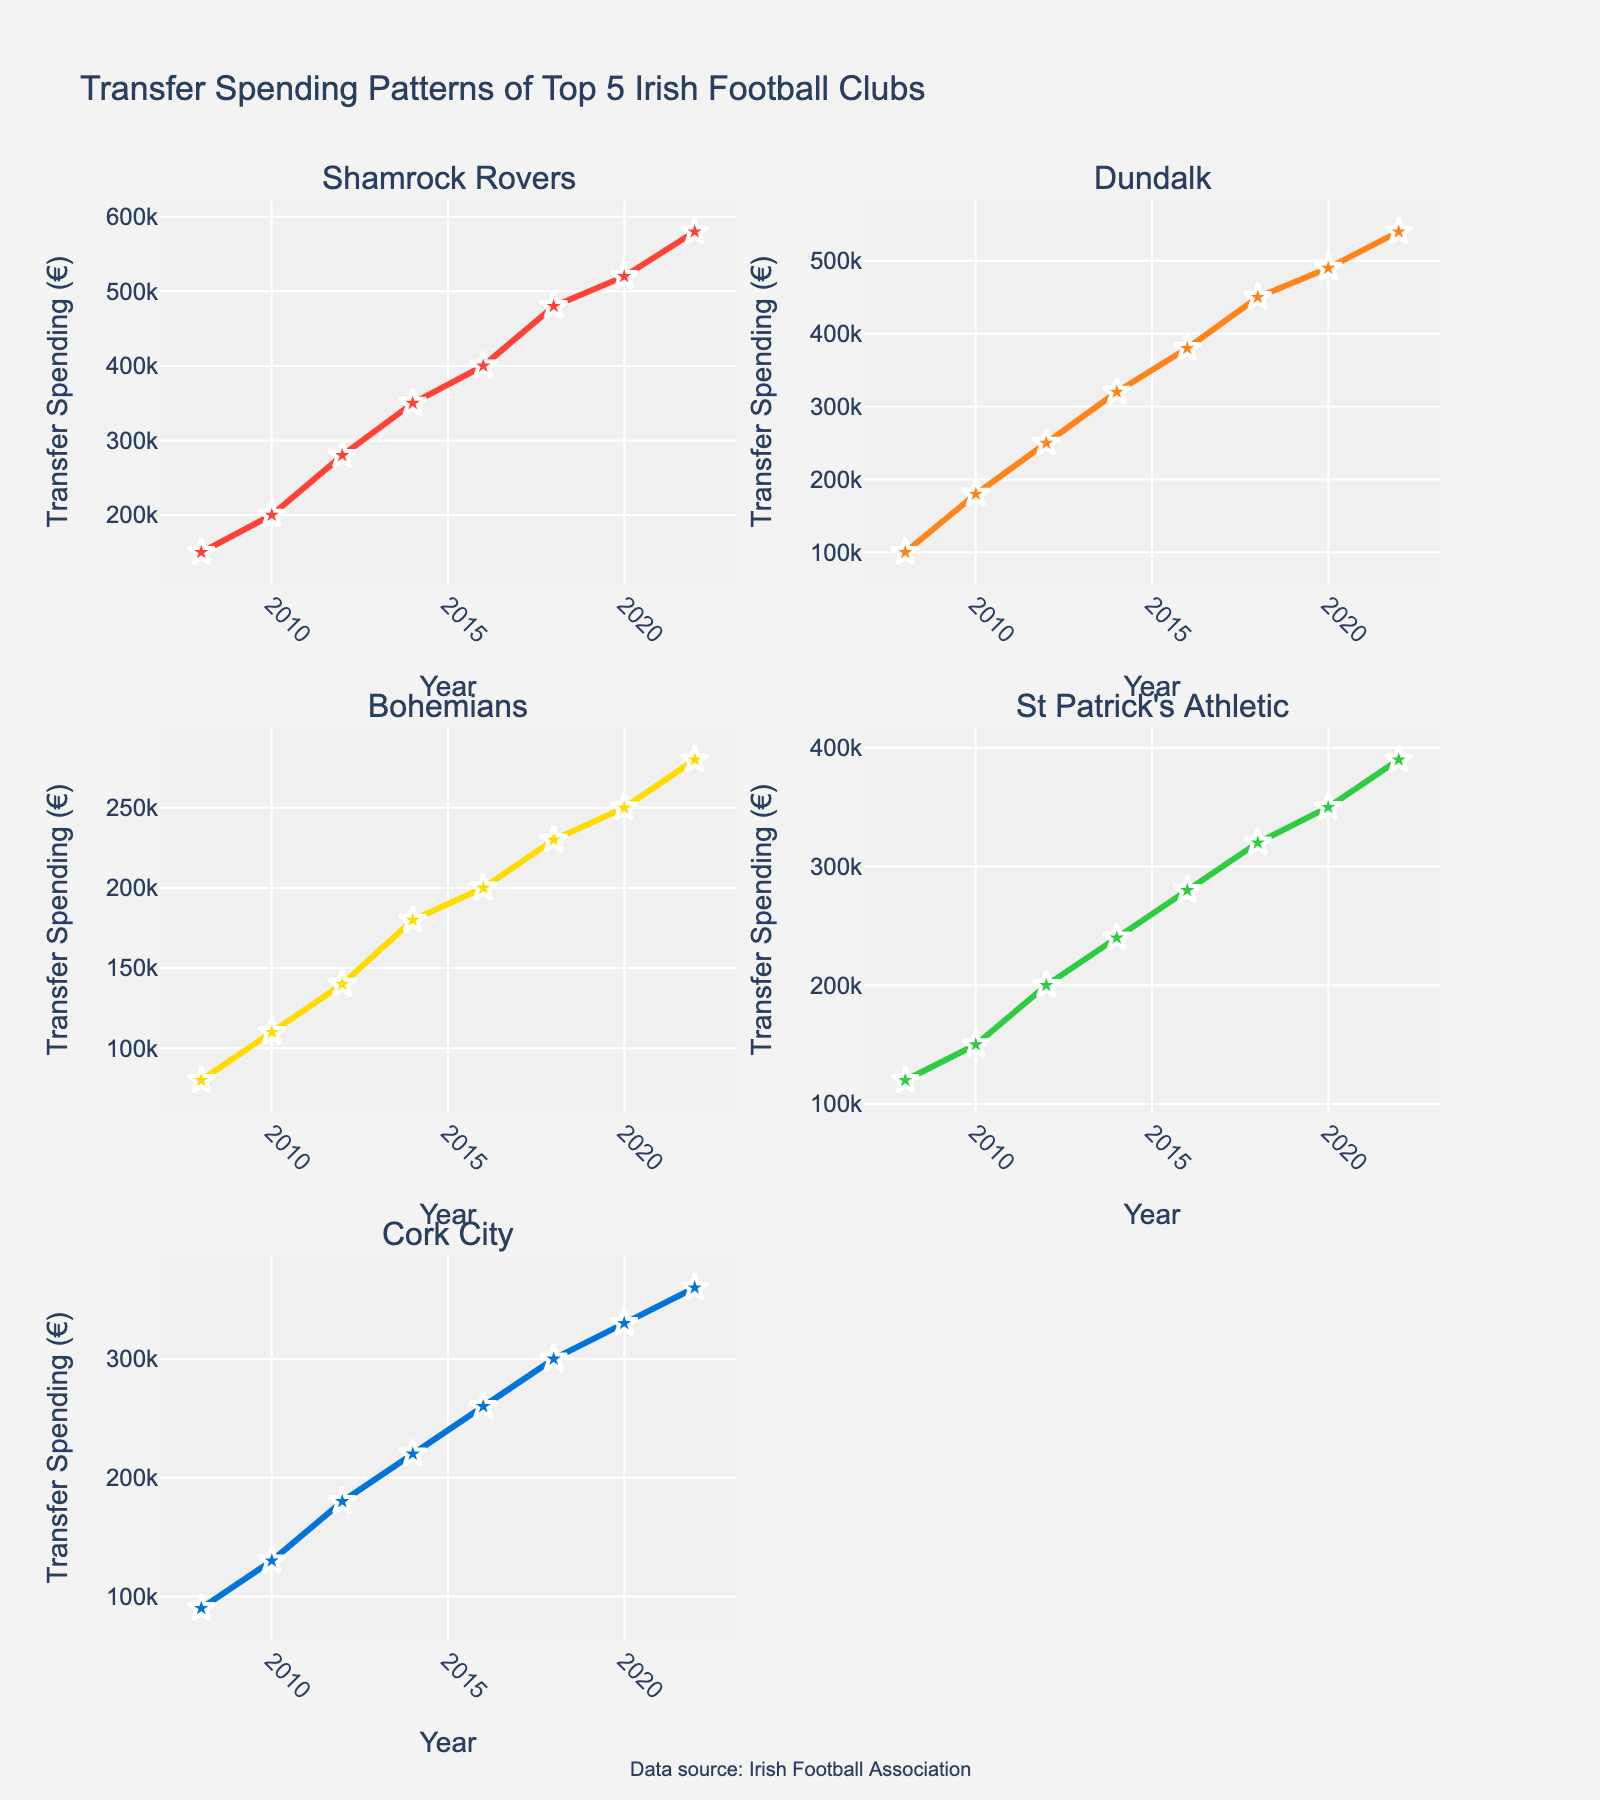what is the total transfer spending of Shamrock Rovers from 2008 to 2022? Sum up the transfer spending of Shamrock Rovers for each year from 2008 to 2022: 150000 + 200000 + 280000 + 350000 + 400000 + 480000 + 520000 + 580000
Answer: 2,960,000 Which club had the highest transfer spending in 2016? Look at the plot for the year 2016 and identify which club has the highest value on the y-axis
Answer: Dundalk What's the average transfer spending of Cork City from 2008 to 2022? Sum up the annual transfer spending for Cork City: 90000 + 130000 + 180000 + 220000 + 260000 + 300000 + 330000 + 360000 = 1,870,000. Divide by the number of years (8): 1,870,000 / 8
Answer: 233,750 Did Bohemians ever surpass St Patrick's Athletic in transfer spending between 2008 and 2022? Compare the transfer spending of Bohemians and St Patrick's Athletic year by year from 2008 to 2022. Bohemians never surpasses St Patrick's Athletic in any year
Answer: No How many clubs had a transfer spending of at least 320,000 in 2018? Look at the subplots for the year 2018 and count the clubs with a spending of 320000 or more
Answer: 4 What was the trend of Shamrock Rovers' transfer spending from 2008 to 2022? Examine the plot for Shamrock Rovers and describe the pattern of the line. The line shows an increasing trend with spending rising more consistently over the years
Answer: Increasing How does the transfer spending pattern of Dundalk compare to Cork City from 2012 to 2022? Compare the lines for Dundalk and Cork City between 2012 and 2022. Dundalk's transfer spending shows a higher and more rapid increase than Cork City's
Answer: Dundalk's spending increased more rapidly Which club had the smallest increase in transfer spending from 2010 to 2022? Calculate the difference in transfer spending between 2010 and 2022 for each club and identify which club has the smallest increase
Answer: Bohemians What year did St Patrick's Athletic surpass 200,000 in transfer spending? Check the plot for St Patrick's Athletic and find the first year the y-axis value exceeds 200,000
Answer: 2012 What was the transfer spending of Bohemians in the year 2016? Locate the data point on Bohemians' subplot for the year 2016
Answer: 200,000 